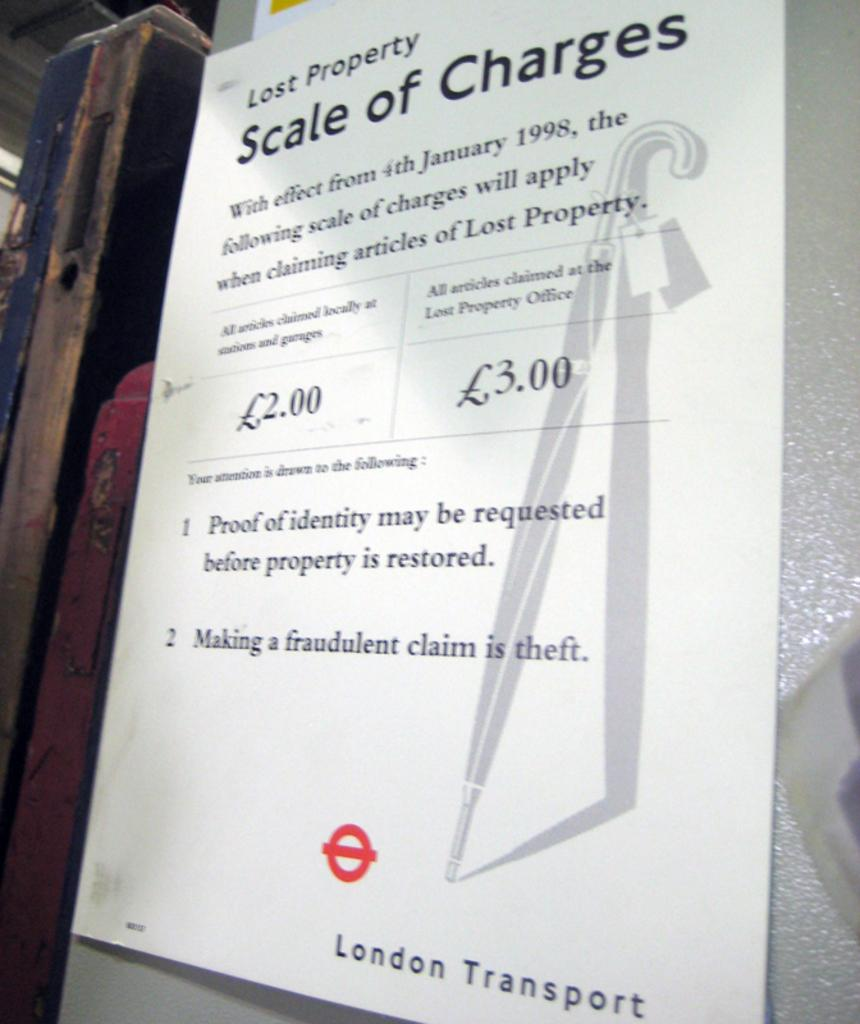Provide a one-sentence caption for the provided image. A london transport lost property scale of charges paper. 